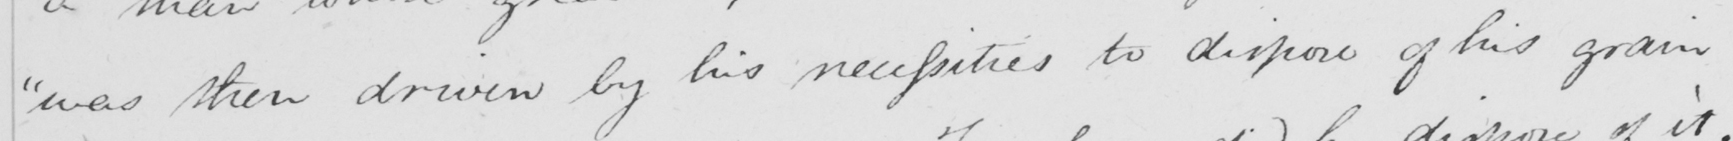Please provide the text content of this handwritten line. " was then driven by his necessities to dispose of his grain 